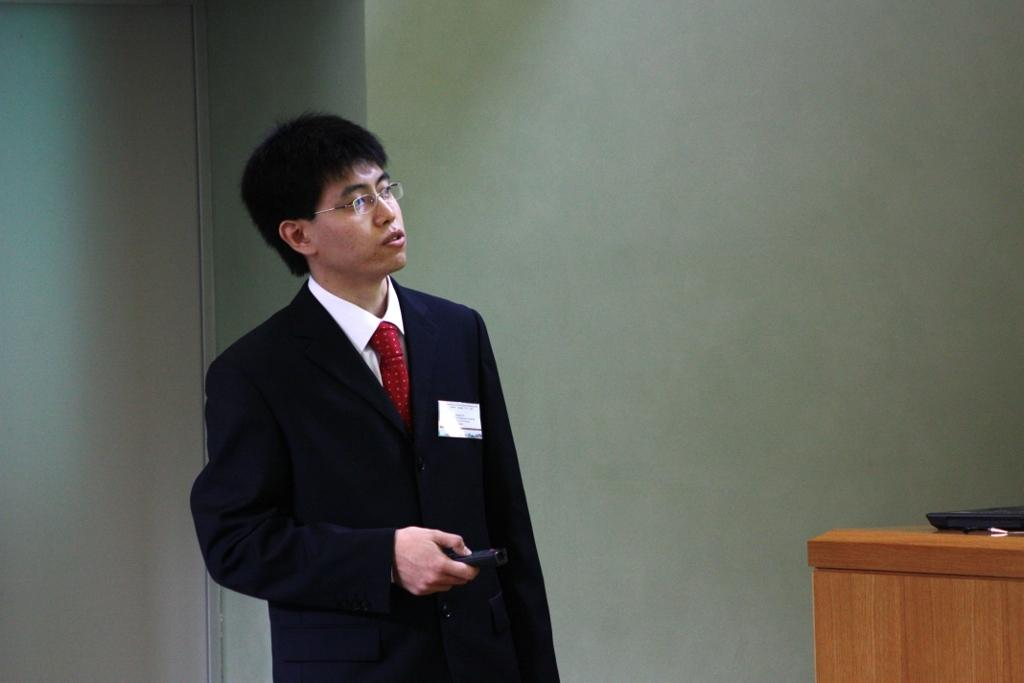What is the person in the image doing? The person is standing in the image. What is the person wearing? The person is wearing a black coat and a red tie. What is the person holding in the image? The person is holding something, but we cannot determine what it is from the facts provided. What is the color of the table in the image? The table in the image is brown. What colors are present on the wall in the image? The wall in the image is white and grey in color. How many zebras can be seen in the image? There are no zebras present in the image. What color are the crayons on the table in the image? There are no crayons present in the image. 